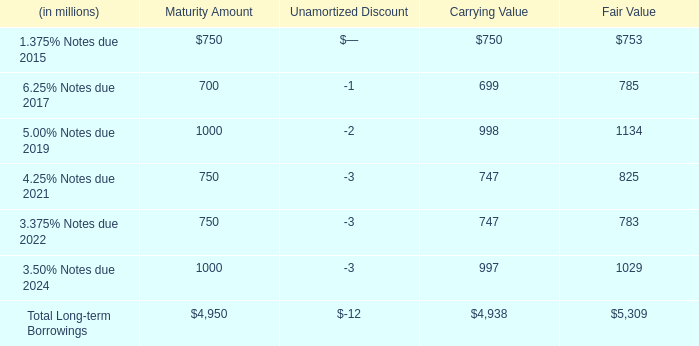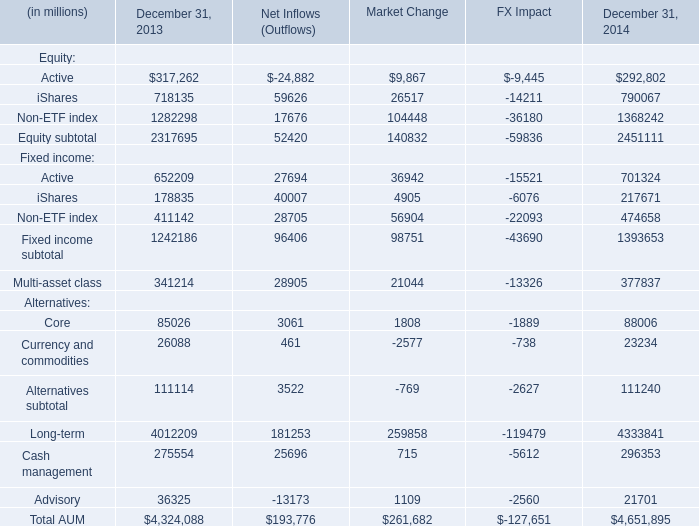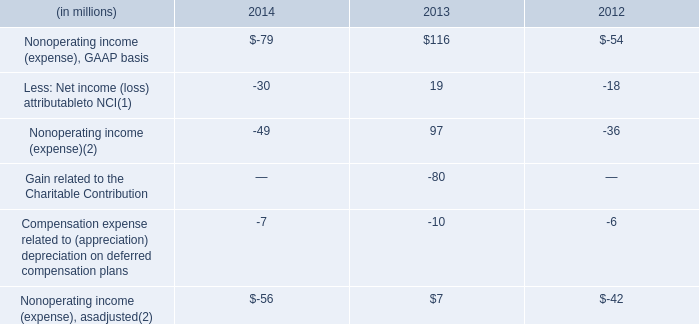What's the sum of equity in 2014? (in dollars in millions) 
Computations: (((292802 + 790067) + 1368242) + 2451111)
Answer: 4902222.0. 